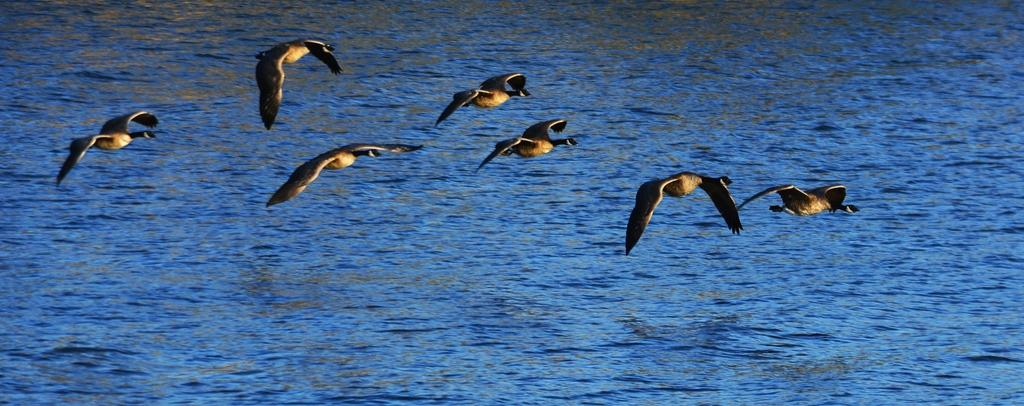What type of animals can be seen in the image? There are birds in the image. Where are the birds located in the image? The birds are in the middle of the image. What can be seen in the background of the image? There is a sea in the background of the image. What type of produce is being discussed in the office setting depicted in the image? There is no office setting or produce mentioned in the image; it features birds in the middle of the image with a sea in the background. 